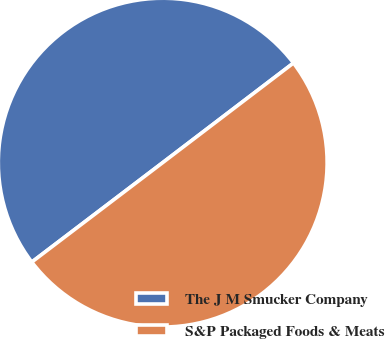<chart> <loc_0><loc_0><loc_500><loc_500><pie_chart><fcel>The J M Smucker Company<fcel>S&P Packaged Foods & Meats<nl><fcel>49.98%<fcel>50.02%<nl></chart> 